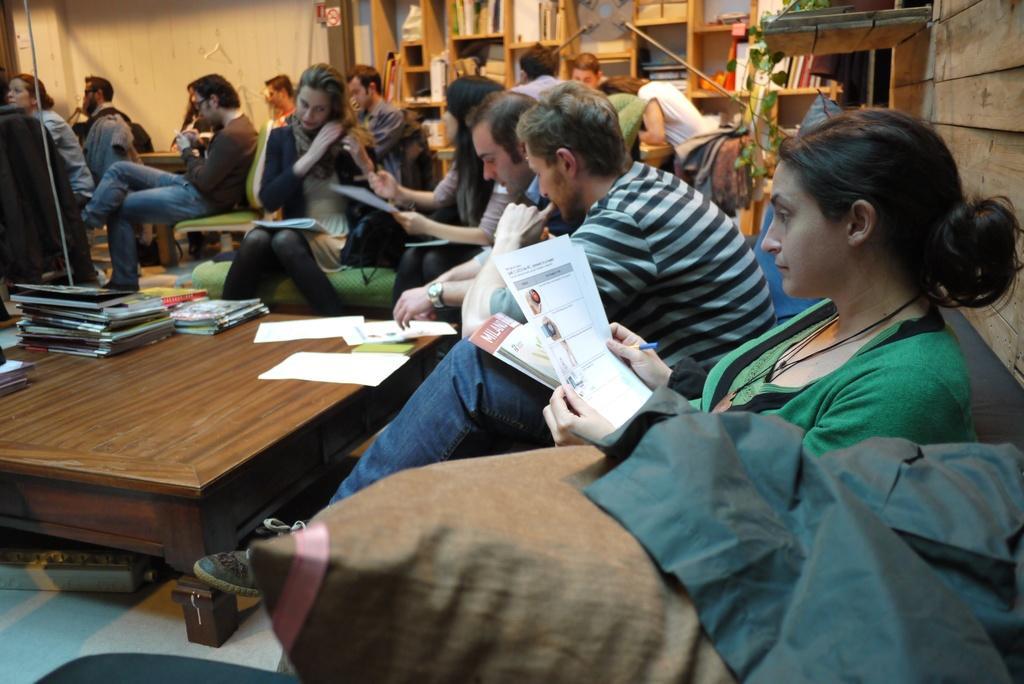Can you describe this image briefly? On the right there is a woman who is wearing green t-shirt, pocket, jeans and shoe. She is holding papers and pen. She is sitting on the couch. Here we can see two men who are sitting near to the table. On the table we can see papers, mobile phone, books, files and other objects. On the background we can see many persons who are sitting on the chair. On the top we can see some books in this a wooden rack. 